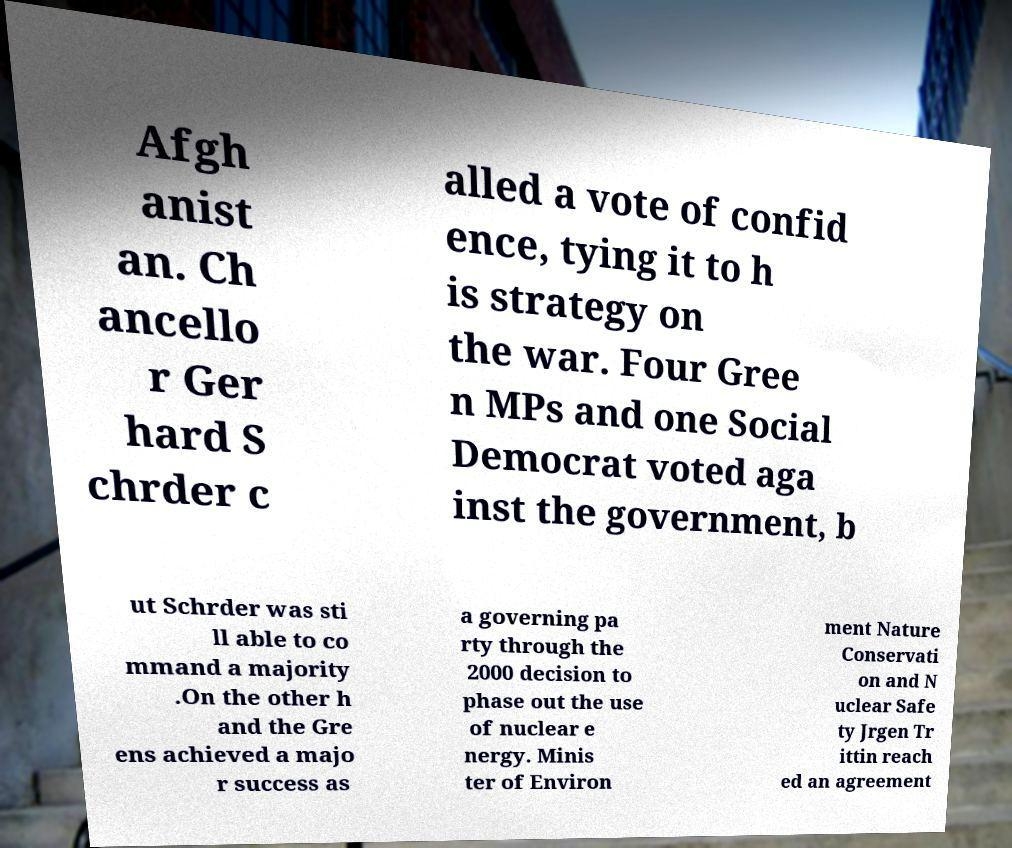Can you read and provide the text displayed in the image?This photo seems to have some interesting text. Can you extract and type it out for me? Afgh anist an. Ch ancello r Ger hard S chrder c alled a vote of confid ence, tying it to h is strategy on the war. Four Gree n MPs and one Social Democrat voted aga inst the government, b ut Schrder was sti ll able to co mmand a majority .On the other h and the Gre ens achieved a majo r success as a governing pa rty through the 2000 decision to phase out the use of nuclear e nergy. Minis ter of Environ ment Nature Conservati on and N uclear Safe ty Jrgen Tr ittin reach ed an agreement 